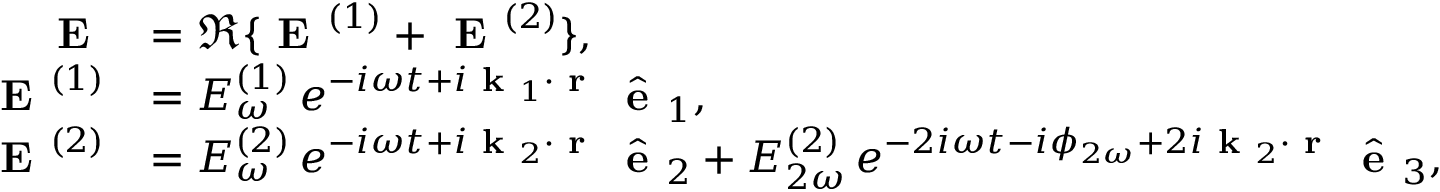Convert formula to latex. <formula><loc_0><loc_0><loc_500><loc_500>\begin{array} { r l } { E } & { = \Re \{ E ^ { ( 1 ) } + E ^ { ( 2 ) } \} , } \\ { E ^ { ( 1 ) } } & { = E _ { \omega } ^ { ( 1 ) } \, e ^ { - i \omega t + i k _ { 1 } \cdot r } \, \hat { e } _ { 1 } , } \\ { E ^ { ( 2 ) } } & { = E _ { \omega } ^ { ( 2 ) } \, e ^ { - i \omega t + i k _ { 2 } \cdot r } \, \hat { e } _ { 2 } + E _ { 2 \omega } ^ { ( 2 ) } \, e ^ { - 2 i \omega t - i \phi _ { 2 \omega } + 2 i k _ { 2 } \cdot r } \, \hat { e } _ { 3 } , } \end{array}</formula> 